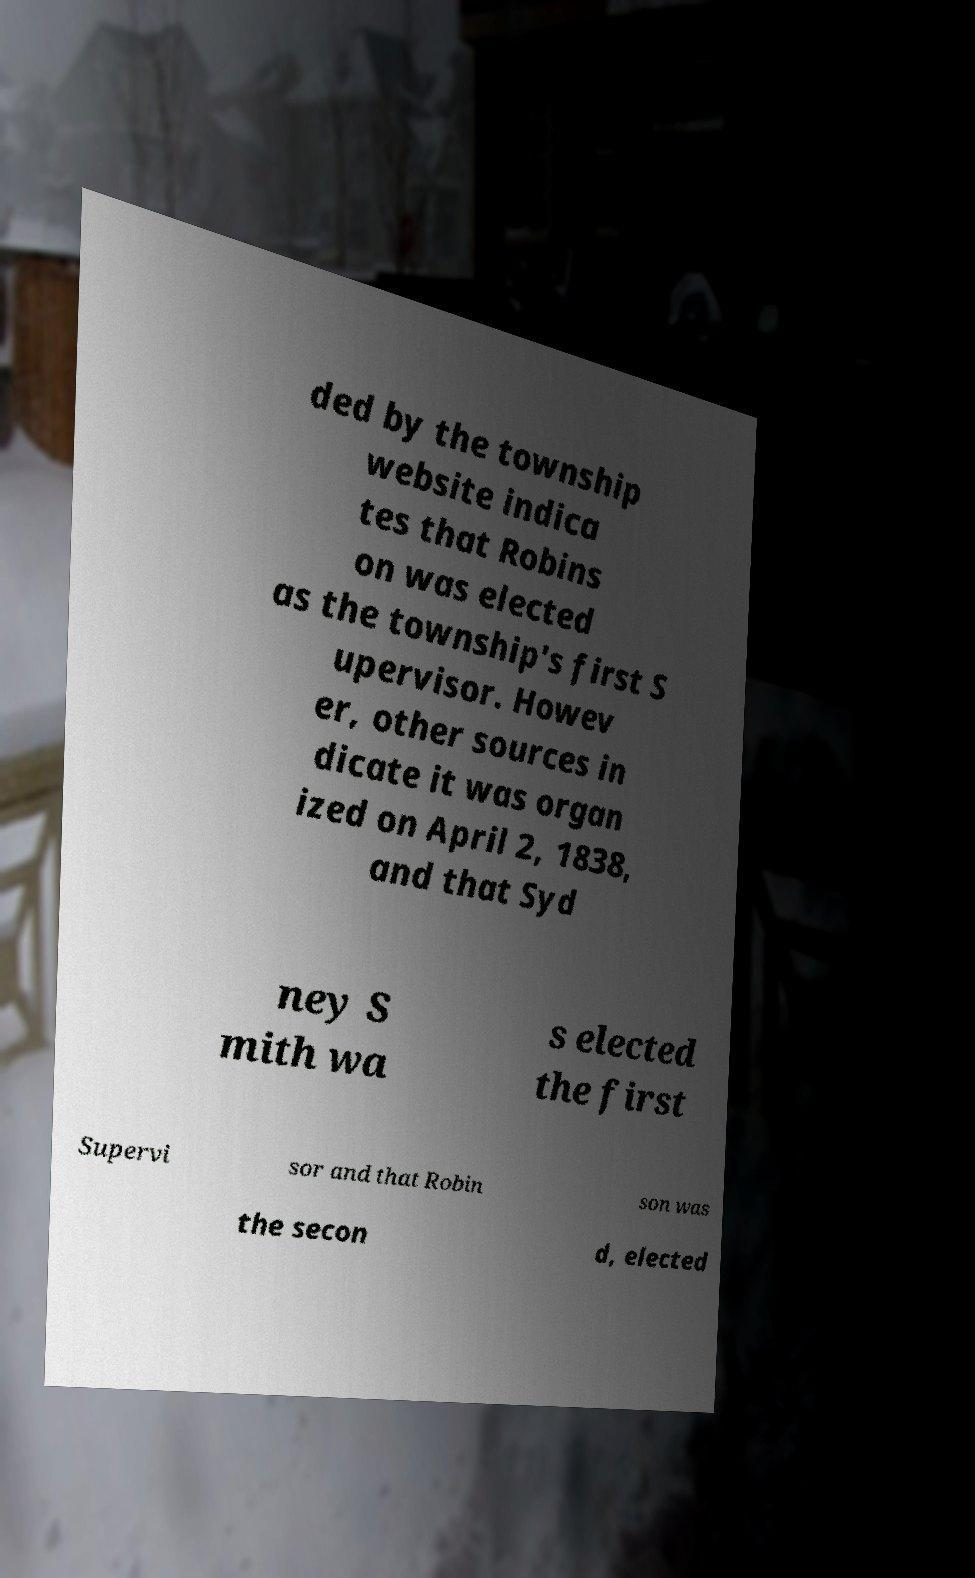Could you assist in decoding the text presented in this image and type it out clearly? ded by the township website indica tes that Robins on was elected as the township's first S upervisor. Howev er, other sources in dicate it was organ ized on April 2, 1838, and that Syd ney S mith wa s elected the first Supervi sor and that Robin son was the secon d, elected 